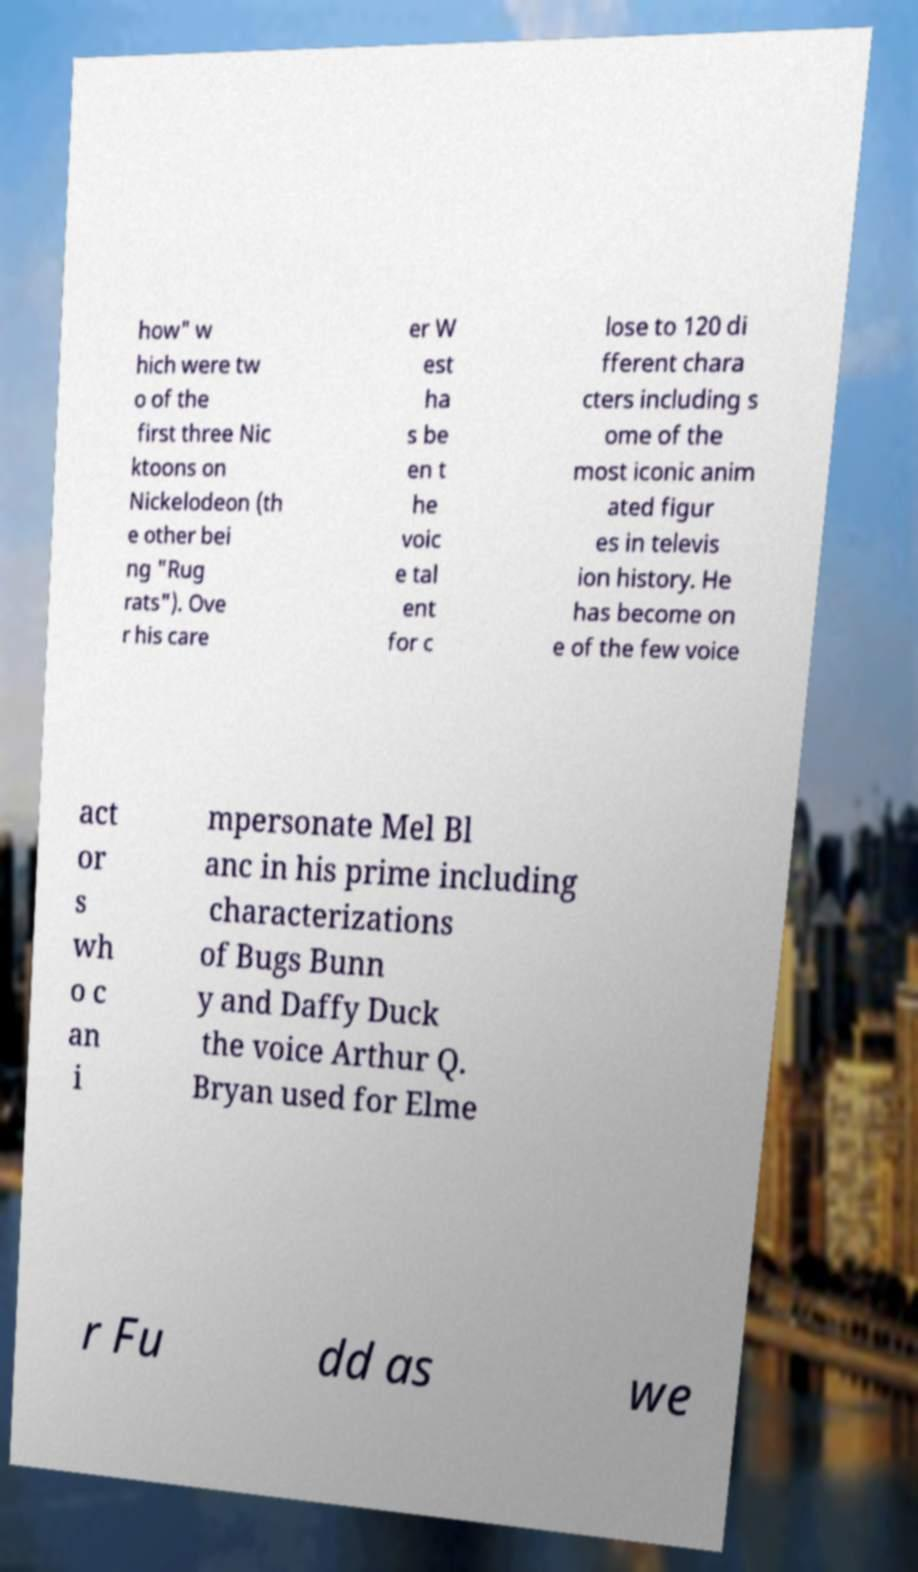What messages or text are displayed in this image? I need them in a readable, typed format. how" w hich were tw o of the first three Nic ktoons on Nickelodeon (th e other bei ng "Rug rats"). Ove r his care er W est ha s be en t he voic e tal ent for c lose to 120 di fferent chara cters including s ome of the most iconic anim ated figur es in televis ion history. He has become on e of the few voice act or s wh o c an i mpersonate Mel Bl anc in his prime including characterizations of Bugs Bunn y and Daffy Duck the voice Arthur Q. Bryan used for Elme r Fu dd as we 